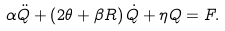<formula> <loc_0><loc_0><loc_500><loc_500>\alpha \ddot { Q } + \left ( 2 \theta + \beta R \right ) \dot { Q } + \eta Q = F .</formula> 